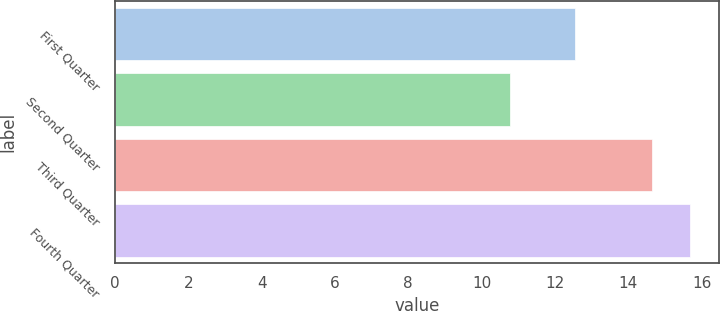<chart> <loc_0><loc_0><loc_500><loc_500><bar_chart><fcel>First Quarter<fcel>Second Quarter<fcel>Third Quarter<fcel>Fourth Quarter<nl><fcel>12.54<fcel>10.77<fcel>14.65<fcel>15.68<nl></chart> 